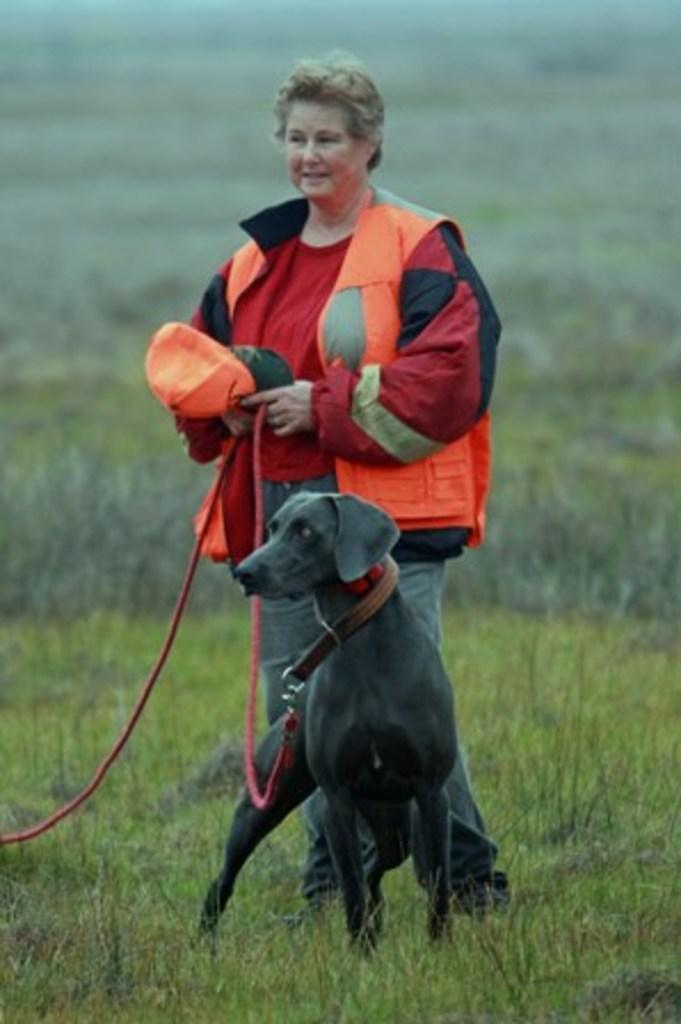Who is present in the image? There is a woman in the image. What is the woman holding in her hand? The woman is holding a cap in her hand. Where is the woman standing? The woman is standing on the grass. What is the woman doing with the dog? The woman is holding a dog with a leash. Can you describe the background of the image? The background of the image is blurry. What type of trees can be seen crying in the image? There are no trees present in the image, and trees do not have the ability to cry. 